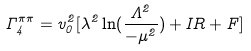Convert formula to latex. <formula><loc_0><loc_0><loc_500><loc_500>\Gamma _ { 4 } ^ { \pi \pi } = v _ { 0 } ^ { 2 } [ \lambda ^ { 2 } \ln ( \frac { \Lambda ^ { 2 } } { - \mu ^ { 2 } } ) + I R + F ]</formula> 